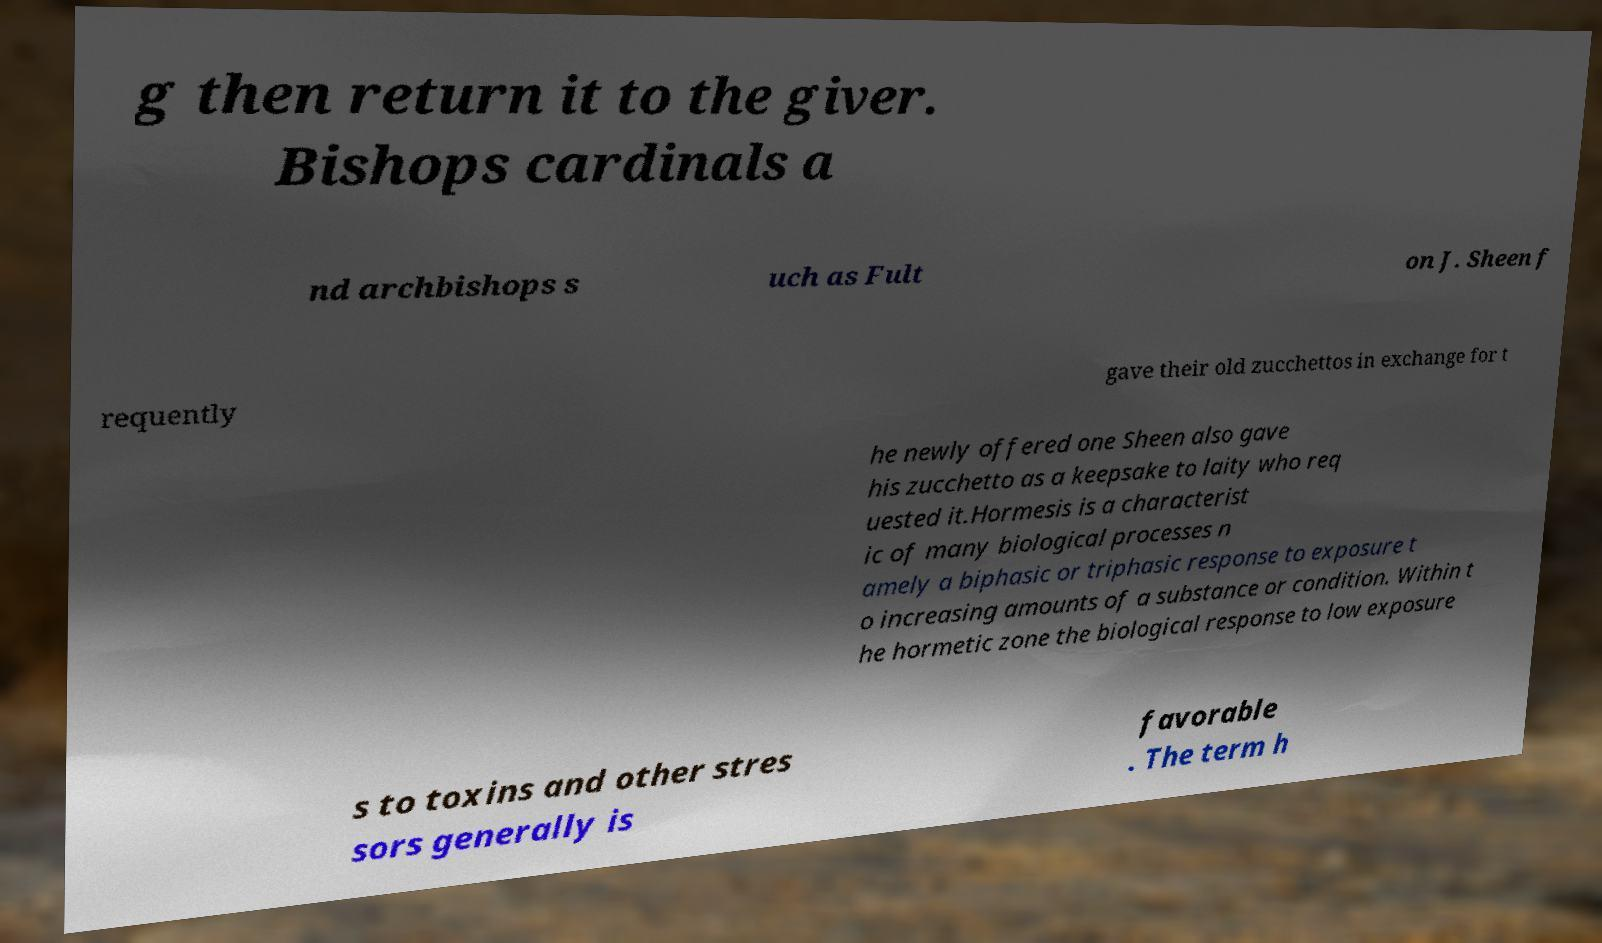Please read and relay the text visible in this image. What does it say? g then return it to the giver. Bishops cardinals a nd archbishops s uch as Fult on J. Sheen f requently gave their old zucchettos in exchange for t he newly offered one Sheen also gave his zucchetto as a keepsake to laity who req uested it.Hormesis is a characterist ic of many biological processes n amely a biphasic or triphasic response to exposure t o increasing amounts of a substance or condition. Within t he hormetic zone the biological response to low exposure s to toxins and other stres sors generally is favorable . The term h 